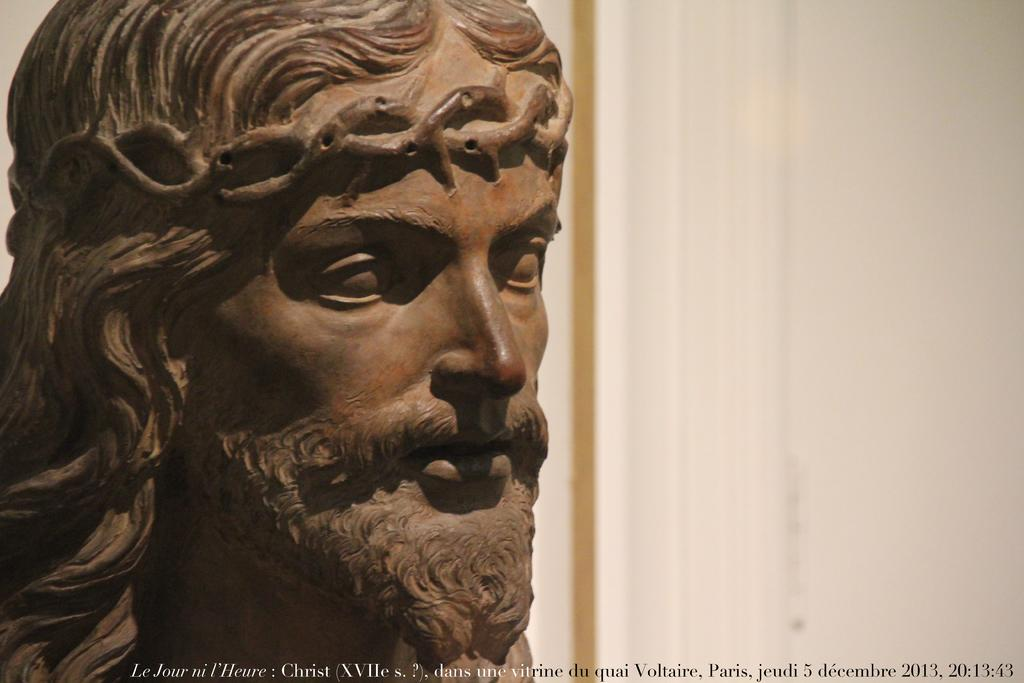What is the main subject in the image? There is a sculpture in the image. What is the color of the sculpture? The sculpture is in brown color. What can be seen on the right side of the image? There is a wall on the right side of the image. What type of guitar is being played by the sculpture in the image? There is no guitar present in the image; it features a sculpture and a wall. What is the stomach size of the sculpture in the image? The sculpture does not have a stomach, as it is an inanimate object and not a living being. 